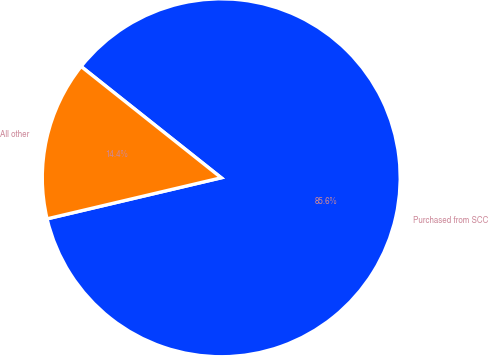<chart> <loc_0><loc_0><loc_500><loc_500><pie_chart><fcel>Purchased from SCC<fcel>All other<nl><fcel>85.63%<fcel>14.37%<nl></chart> 